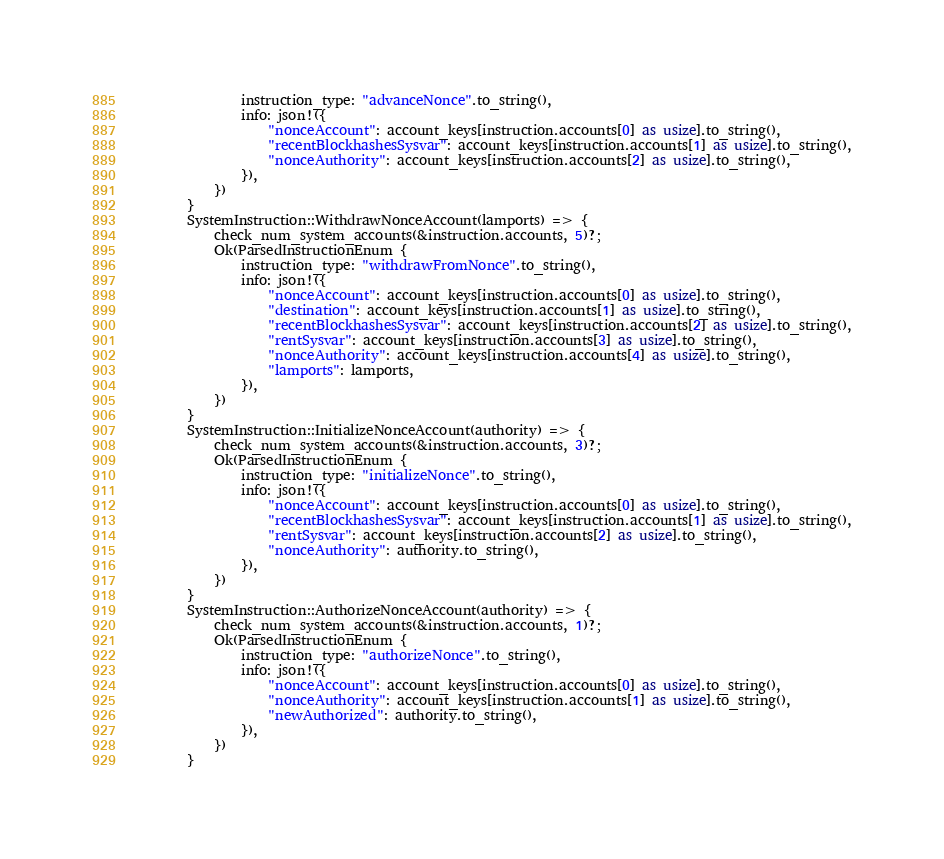<code> <loc_0><loc_0><loc_500><loc_500><_Rust_>                instruction_type: "advanceNonce".to_string(),
                info: json!({
                    "nonceAccount": account_keys[instruction.accounts[0] as usize].to_string(),
                    "recentBlockhashesSysvar": account_keys[instruction.accounts[1] as usize].to_string(),
                    "nonceAuthority": account_keys[instruction.accounts[2] as usize].to_string(),
                }),
            })
        }
        SystemInstruction::WithdrawNonceAccount(lamports) => {
            check_num_system_accounts(&instruction.accounts, 5)?;
            Ok(ParsedInstructionEnum {
                instruction_type: "withdrawFromNonce".to_string(),
                info: json!({
                    "nonceAccount": account_keys[instruction.accounts[0] as usize].to_string(),
                    "destination": account_keys[instruction.accounts[1] as usize].to_string(),
                    "recentBlockhashesSysvar": account_keys[instruction.accounts[2] as usize].to_string(),
                    "rentSysvar": account_keys[instruction.accounts[3] as usize].to_string(),
                    "nonceAuthority": account_keys[instruction.accounts[4] as usize].to_string(),
                    "lamports": lamports,
                }),
            })
        }
        SystemInstruction::InitializeNonceAccount(authority) => {
            check_num_system_accounts(&instruction.accounts, 3)?;
            Ok(ParsedInstructionEnum {
                instruction_type: "initializeNonce".to_string(),
                info: json!({
                    "nonceAccount": account_keys[instruction.accounts[0] as usize].to_string(),
                    "recentBlockhashesSysvar": account_keys[instruction.accounts[1] as usize].to_string(),
                    "rentSysvar": account_keys[instruction.accounts[2] as usize].to_string(),
                    "nonceAuthority": authority.to_string(),
                }),
            })
        }
        SystemInstruction::AuthorizeNonceAccount(authority) => {
            check_num_system_accounts(&instruction.accounts, 1)?;
            Ok(ParsedInstructionEnum {
                instruction_type: "authorizeNonce".to_string(),
                info: json!({
                    "nonceAccount": account_keys[instruction.accounts[0] as usize].to_string(),
                    "nonceAuthority": account_keys[instruction.accounts[1] as usize].to_string(),
                    "newAuthorized": authority.to_string(),
                }),
            })
        }</code> 